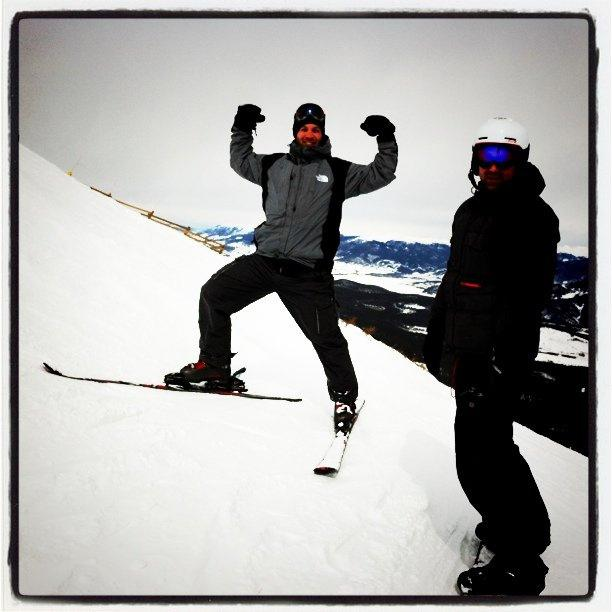What muscles in the male showing off? Please explain your reasoning. biceps. The man is showing his arms. 